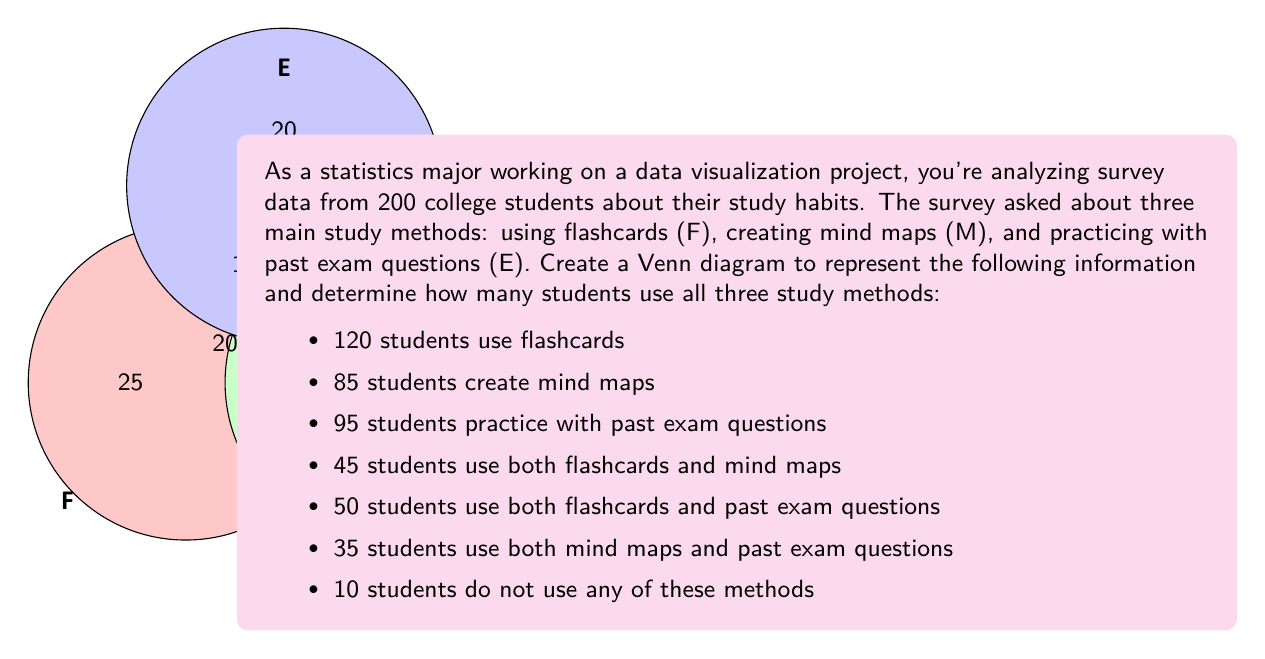Help me with this question. Let's approach this step-by-step:

1) First, we need to set up our Venn diagram with three intersecting circles representing F (Flashcards), M (Mind maps), and E (Exam questions).

2) We're given that 10 students don't use any method, so we put 10 outside all circles.

3) Now, let's fill in the known intersections:
   - F ∩ M = 45
   - F ∩ E = 50
   - M ∩ E = 35

4) Let x be the number of students using all three methods (F ∩ M ∩ E).

5) We can now set up equations for each circle:
   F: 120 = (45 - x) + (50 - x) + x + (25 + x) = 120
   M: 85 = (45 - x) + (35 - x) + x + (15 + x) = 85
   E: 95 = (50 - x) + (35 - x) + x + (20 + x) = 95

6) From the F equation:
   120 = 120 + x
   x = 20

7) We can verify this in the other equations:
   M: 85 = 45 + 35 + 15 - x = 95 - 10 = 85 ✓
   E: 95 = 50 + 35 + 20 - x = 105 - 10 = 95 ✓

8) Now we can fill in the rest of the Venn diagram:
   - F only: 25
   - M only: 15
   - E only: 20
   - F ∩ M only: 25
   - F ∩ E only: 30
   - M ∩ E only: 15
   - F ∩ M ∩ E: 20

9) We can verify the total:
   25 + 15 + 20 + 25 + 30 + 15 + 20 + 10 = 160

Therefore, 20 students use all three study methods.
Answer: 20 students 